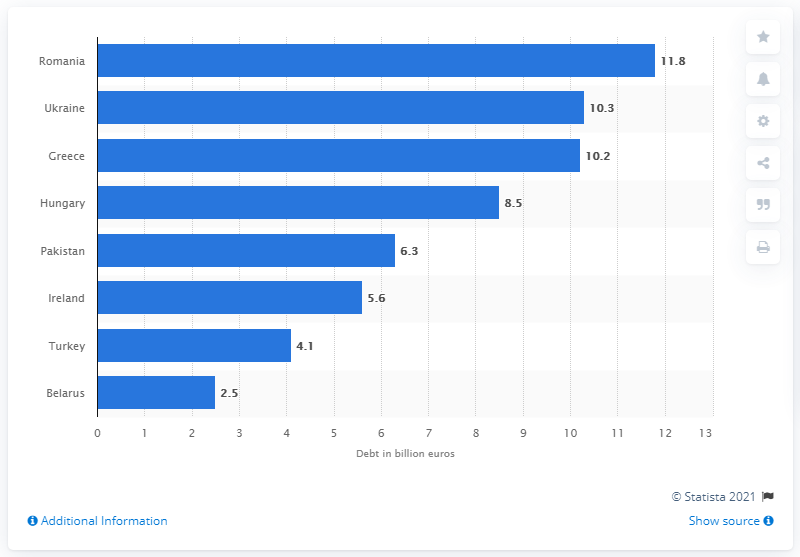Mention a couple of crucial points in this snapshot. In May 2011, Belarus was the largest debtor state. In May 2011, Belarus's debt was $2.5 billion. 